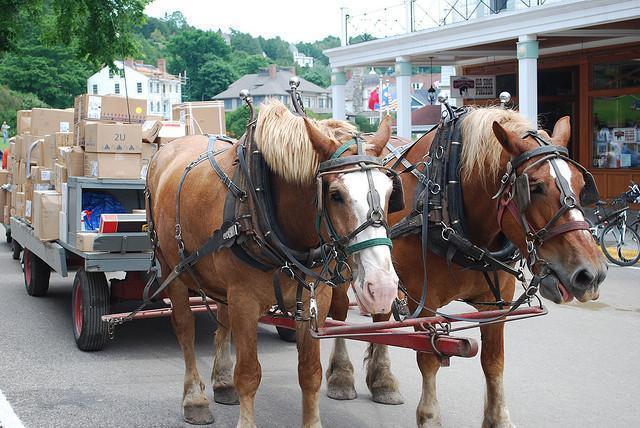How many horses are there?
Give a very brief answer. 2. 